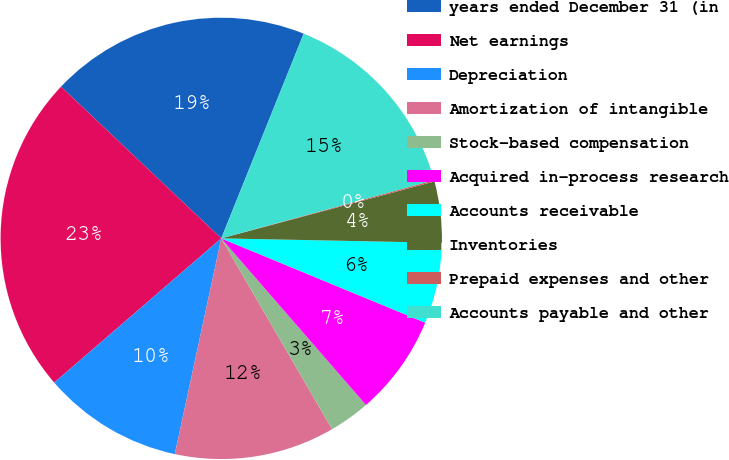Convert chart to OTSL. <chart><loc_0><loc_0><loc_500><loc_500><pie_chart><fcel>years ended December 31 (in<fcel>Net earnings<fcel>Depreciation<fcel>Amortization of intangible<fcel>Stock-based compensation<fcel>Acquired in-process research<fcel>Accounts receivable<fcel>Inventories<fcel>Prepaid expenses and other<fcel>Accounts payable and other<nl><fcel>19.03%<fcel>23.4%<fcel>10.29%<fcel>11.75%<fcel>3.01%<fcel>7.38%<fcel>5.92%<fcel>4.47%<fcel>0.1%<fcel>14.66%<nl></chart> 